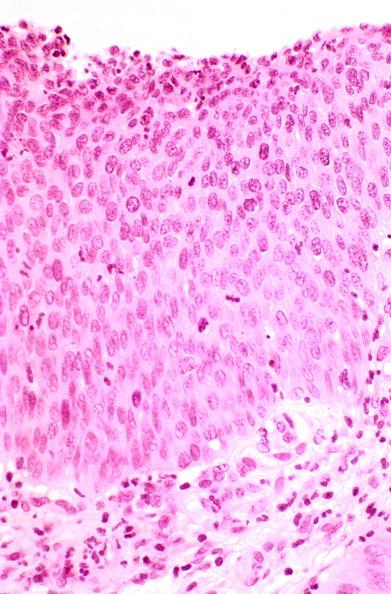does this image show cervix, severe dysplasia to carcinoma in situ?
Answer the question using a single word or phrase. Yes 